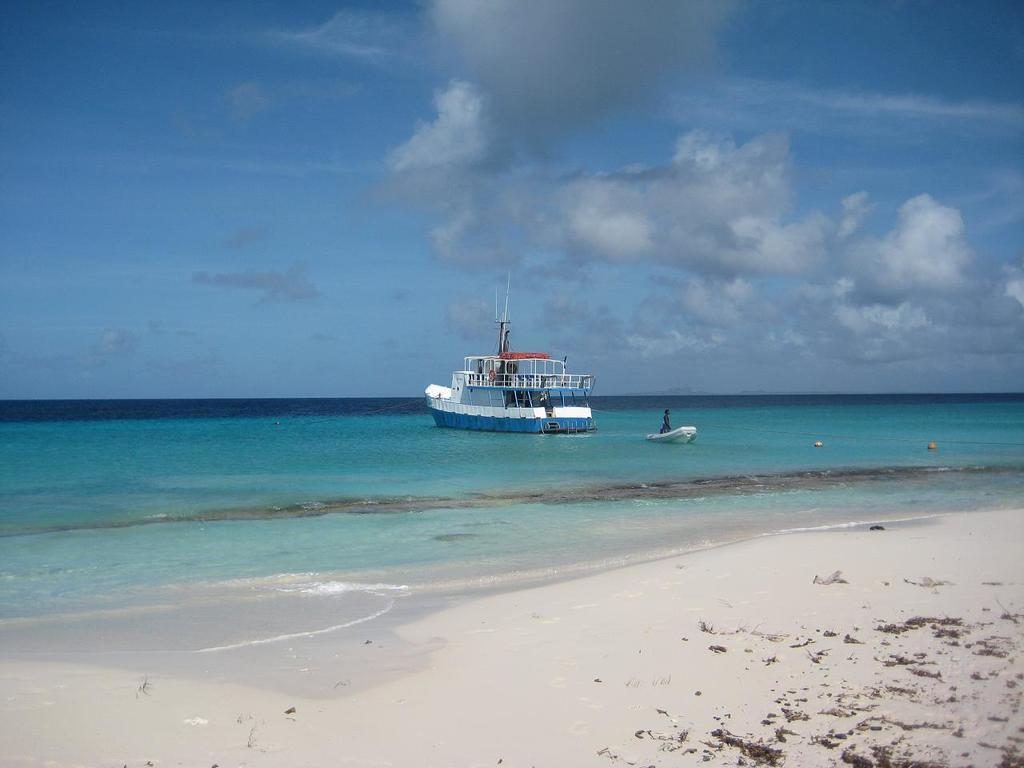What can be seen in the middle of the image? There are two boats in the middle of the image. What is happening with the person in the image? The person is in the water. What can be seen in the background of the image? The sky is visible in the background of the image. Where might this image have been taken? The image may have been taken on a sandy beach. Can you see any cobwebs in the image? There are no cobwebs present in the image. Is there a toad hiding in the sand in the image? There is no toad visible in the image. 